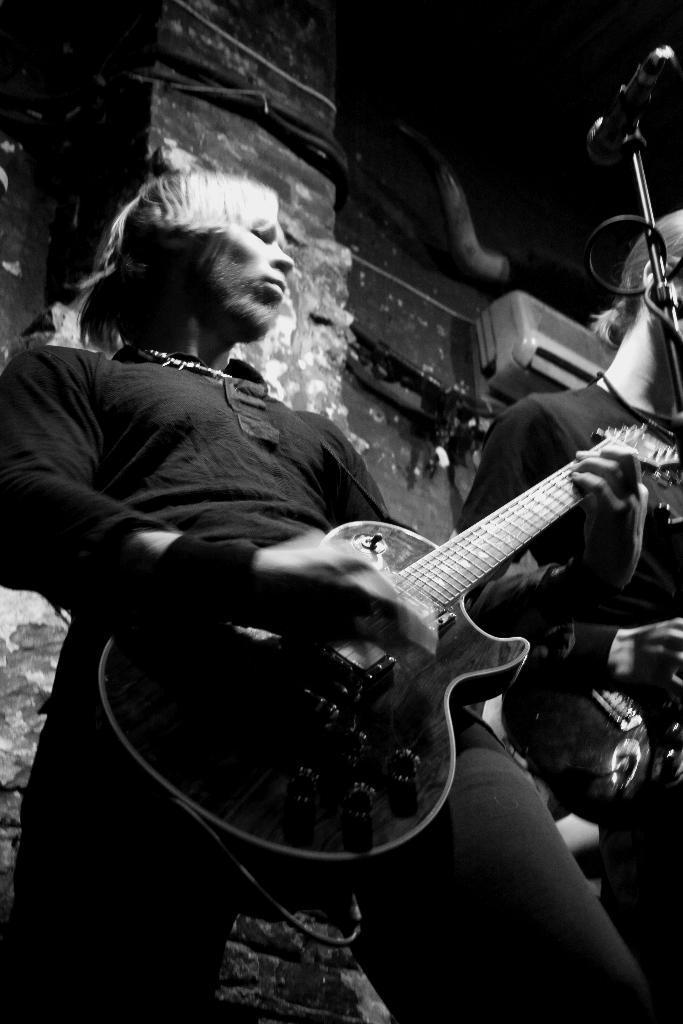Could you give a brief overview of what you see in this image? In this picture we can see a person holding guitar in his hand and playing it aside to him other person standing and in background we can see wall, AC and it is dark. 